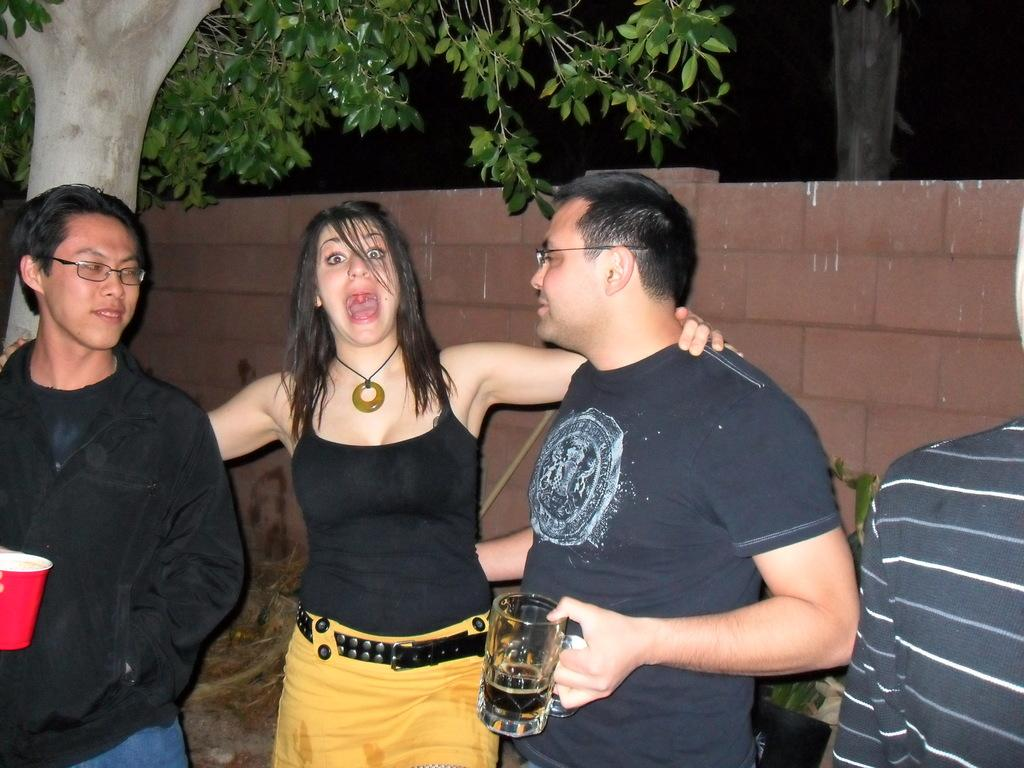How many people are in the image? There are people in the image, but the exact number is not specified. What are the two men holding in the image? The two men are holding glasses in the image. What type of vegetation is present in the image? There is a plant and a tree in the image. What is the color of the wall in the image? The background of the image is dark, but the color of the wall is not specified. What can be seen in the background of the image? A tree trunk is visible in the background of the image. What type of corn is being harvested by the boys in the image? There is no corn or boys present in the image; it features people, glasses, a plant, a wall, a tree, and a dark background. How many apples are on the tree in the image? There is no tree with apples in the image; it features a tree trunk in the background. 